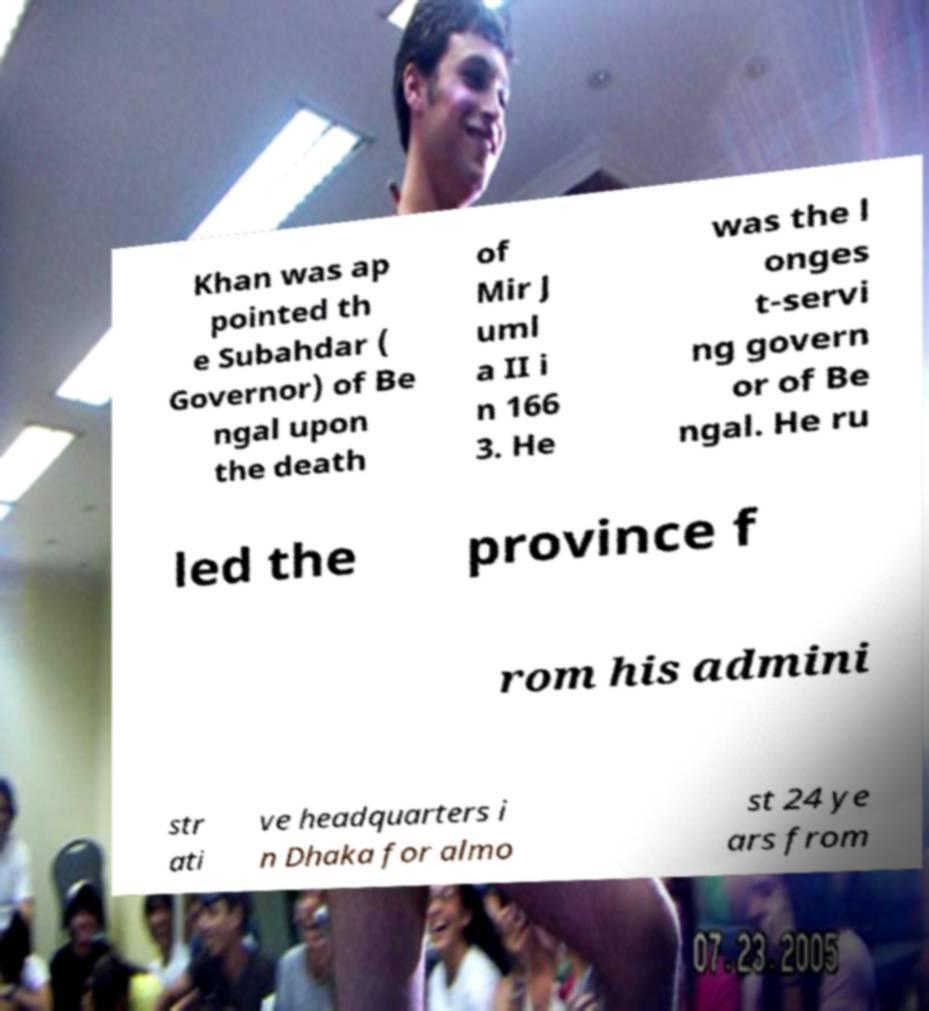Could you assist in decoding the text presented in this image and type it out clearly? Khan was ap pointed th e Subahdar ( Governor) of Be ngal upon the death of Mir J uml a II i n 166 3. He was the l onges t-servi ng govern or of Be ngal. He ru led the province f rom his admini str ati ve headquarters i n Dhaka for almo st 24 ye ars from 